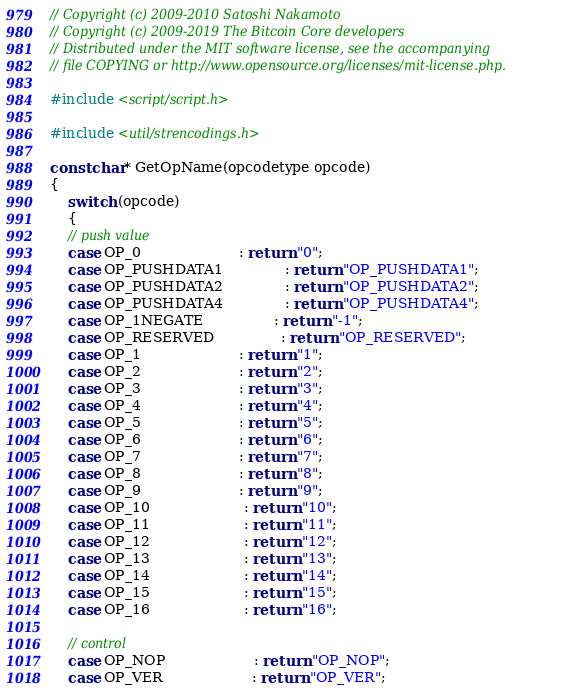Convert code to text. <code><loc_0><loc_0><loc_500><loc_500><_C++_>// Copyright (c) 2009-2010 Satoshi Nakamoto
// Copyright (c) 2009-2019 The Bitcoin Core developers
// Distributed under the MIT software license, see the accompanying
// file COPYING or http://www.opensource.org/licenses/mit-license.php.

#include <script/script.h>

#include <util/strencodings.h>

const char* GetOpName(opcodetype opcode)
{
    switch (opcode)
    {
    // push value
    case OP_0                      : return "0";
    case OP_PUSHDATA1              : return "OP_PUSHDATA1";
    case OP_PUSHDATA2              : return "OP_PUSHDATA2";
    case OP_PUSHDATA4              : return "OP_PUSHDATA4";
    case OP_1NEGATE                : return "-1";
    case OP_RESERVED               : return "OP_RESERVED";
    case OP_1                      : return "1";
    case OP_2                      : return "2";
    case OP_3                      : return "3";
    case OP_4                      : return "4";
    case OP_5                      : return "5";
    case OP_6                      : return "6";
    case OP_7                      : return "7";
    case OP_8                      : return "8";
    case OP_9                      : return "9";
    case OP_10                     : return "10";
    case OP_11                     : return "11";
    case OP_12                     : return "12";
    case OP_13                     : return "13";
    case OP_14                     : return "14";
    case OP_15                     : return "15";
    case OP_16                     : return "16";

    // control
    case OP_NOP                    : return "OP_NOP";
    case OP_VER                    : return "OP_VER";</code> 